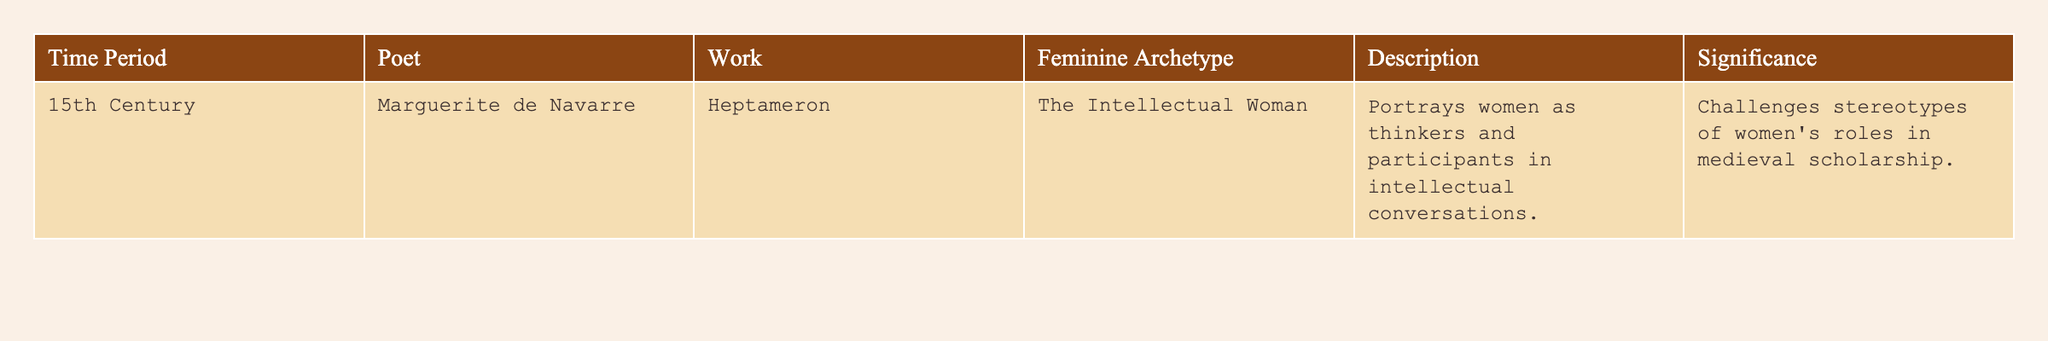What is the name of the poet from the 15th century mentioned in the table? The table specifies that Marguerite de Navarre is the poet associated with the work listed for the 15th century.
Answer: Marguerite de Navarre What archetype does Marguerite de Navarre's work in the table portray? The table indicates that Marguerite de Navarre's work, "Heptameron," portrays the archetype of "The Intellectual Woman."
Answer: The Intellectual Woman What is the significance of the feminine archetype presented in "Heptameron"? According to the table, the significance of the archetype presented is that it challenges stereotypes of women's roles in medieval scholarship.
Answer: Challenges stereotypes Was "Heptameron" created in the 14th century? The table clearly states that "Heptameron" was written in the 15th century, making it false that it was created in the 14th century.
Answer: No How many unique feminine archetypes are listed in the table? The table only contains one row, listing one feminine archetype, which is "The Intellectual Woman." Hence, there is only one unique archetype present.
Answer: 1 What does the description of "The Intellectual Woman" imply about women in medieval literature? The description provided indicates that women are portrayed as thinkers and participants in intellectual conversations, which suggests a more complex representation than traditionally seen in medieval literature.
Answer: More complex representation What significant thematic shift does "The Intellectual Woman" represent in medieval poetry? The archetype showcases a shift from traditional portrayals of passive roles for women in literature to one where women are active participants in intellectual discourse.
Answer: Shift to active participation What can be inferred about women's roles in the 15th century compared to earlier periods based on this work? Based on the table, the portrayal of women as intellectuals suggests an evolution towards greater recognition of women's capabilities in scholarship and thought, contrasting with earlier depictions of women in more submissive roles.
Answer: Greater recognition of capabilities 